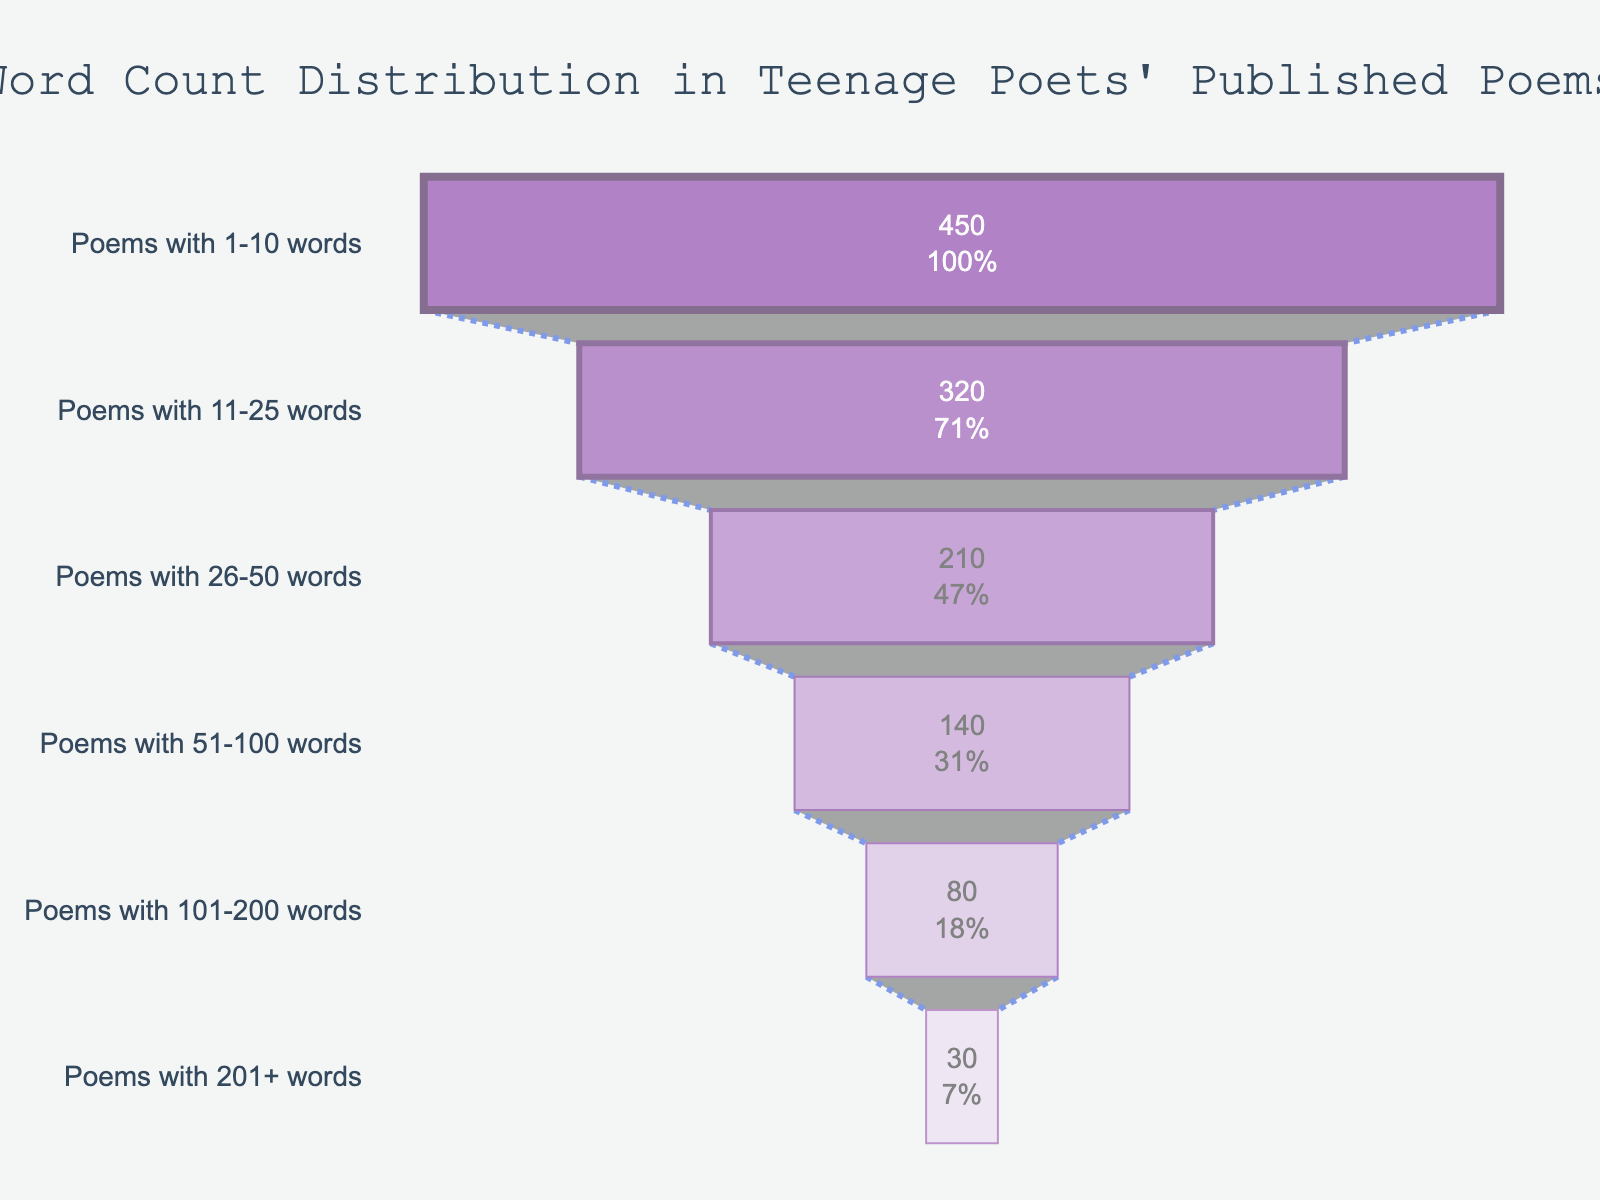What's the title of the funnel chart? The title is typically located at the top of the chart. In this case, it reads "Word Count Distribution in Teenage Poets' Published Poems."
Answer: Word Count Distribution in Teenage Poets' Published Poems Which stage has the highest number of poems? The stage that appears at the widest part of the funnel indicates the highest number of poems. According to the chart, the stage "Poems with 1-10 words" has the highest count.
Answer: Poems with 1-10 words What percentage of the initial number of poems does the stage "Poems with 51-100 words" represent? The stage "Poems with 51-100 words" is displayed as 140 poems. To find the percentage, divide this by the initial number (450) and multiply by 100: (140/450) * 100 = 31.11%.
Answer: 31.11% How many poems have more than 100 words? To find the total number of poems with more than 100 words, sum the poems in the stages "Poems with 101-200 words" and "Poems with 201+ words": 80 + 30 = 110.
Answer: 110 Which two stages have the most similar number of poems? By visually estimating the lengths of the bars, the stages "Poems with 51-100 words" (140 poems) and "Poems with 101-200 words" (80 poems) are closest in number. Calculate the difference: 140 - 80 = 60. This is the smallest gap among the given stages.
Answer: Poems with 51-100 words and Poems with 101-200 words What is the average number of poems in stages with more than 25 words? The relevant stages are: "Poems with 26-50 words" (210), "Poems with 51-100 words" (140), "Poems with 101-200 words" (80), and "Poems with 201+ words" (30). Calculate the total: 210 + 140 + 80 + 30 = 460. Then, divide by 4 stages: 460 / 4 = 115.
Answer: 115 Which color stage represents poems with 11-25 words? Colors can be identified by their position in the chart. The stage "Poems with 11-25 words" is second from the top and is shown in a shade of light purple.
Answer: Light purple How many more poems are there in the stage "Poems with 1-10 words" compared to "Poems with 11-25 words"? The number of poems in "Poems with 1-10 words" is 450 while "Poems with 11-25 words" has 320. Subtract the lower count from the higher count: 450 - 320 = 130.
Answer: 130 What is the combined percentage of poems with 101+ words compared to the initial stage? First sum the poems in "Poems with 101-200 words" (80) and "Poems with 201+ words" (30) for a total of 110. Divide by the initial stage count (450) and multiply by 100: (110/450) * 100 = 24.44%.
Answer: 24.44% 